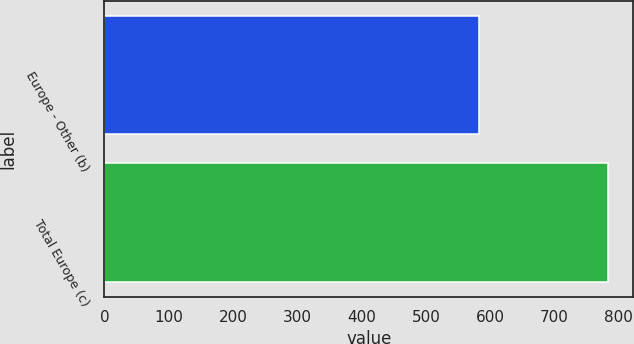Convert chart. <chart><loc_0><loc_0><loc_500><loc_500><bar_chart><fcel>Europe - Other (b)<fcel>Total Europe (c)<nl><fcel>582<fcel>783<nl></chart> 